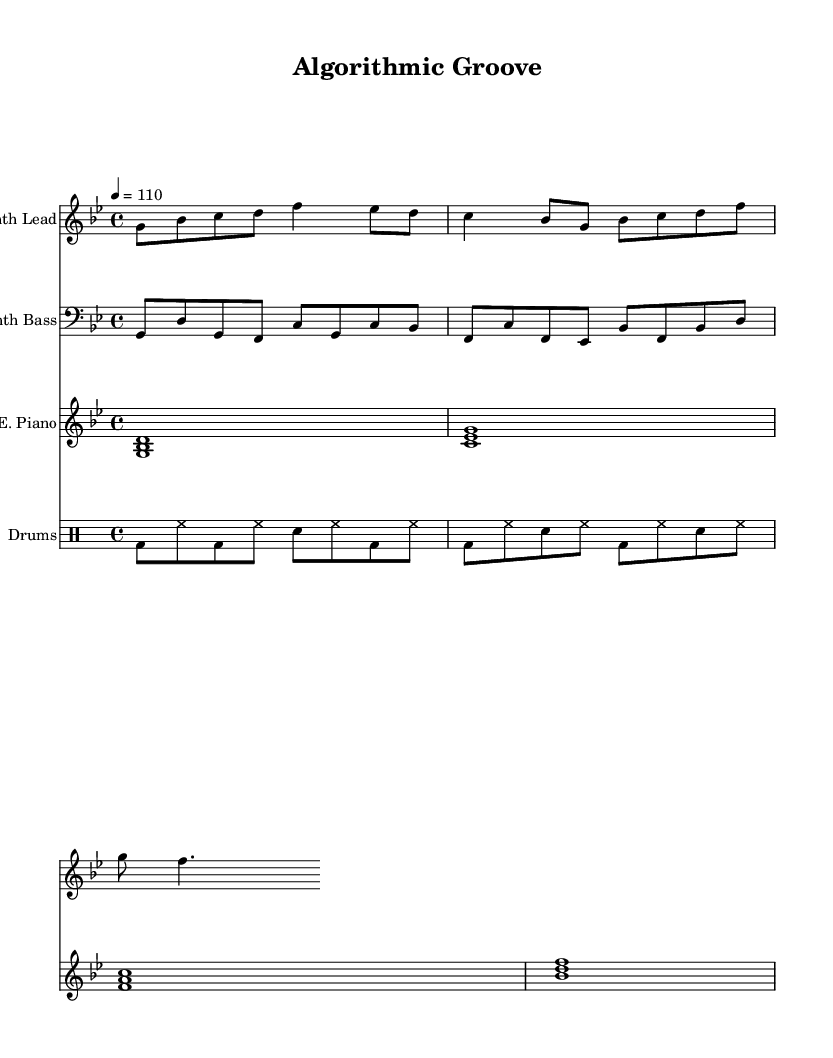What is the key signature of this music? The key signature corresponds to the first part of the global section, \key g \minor, indicating that there are two flats in the key signature.
Answer: G minor What is the time signature of the piece? The time signature is specified in the global section of the code as \time 4/4, indicating four beats per measure.
Answer: 4/4 What is the tempo marking for this composition? The tempo is indicated in the global section as \tempo 4 = 110, which means the piece is played at a speed of 110 beats per minute.
Answer: 110 How many voices are present in this composition? By counting the individual staves created in the \score part of the code, there are four separate parts: Synth Lead, Synth Bass, Electric Piano, and Drums, indicating four distinct voices.
Answer: Four Which instrument plays the bass line? The Synth Bass staff contains the bass line, which is constructed for a bass clef under the \synthBass variable.
Answer: Synth Bass How many measures are present in the electric piano part? By evaluating the notes in the electricPiano variable, there are four chords, which represent four measures corresponding to each chord.
Answer: Four 